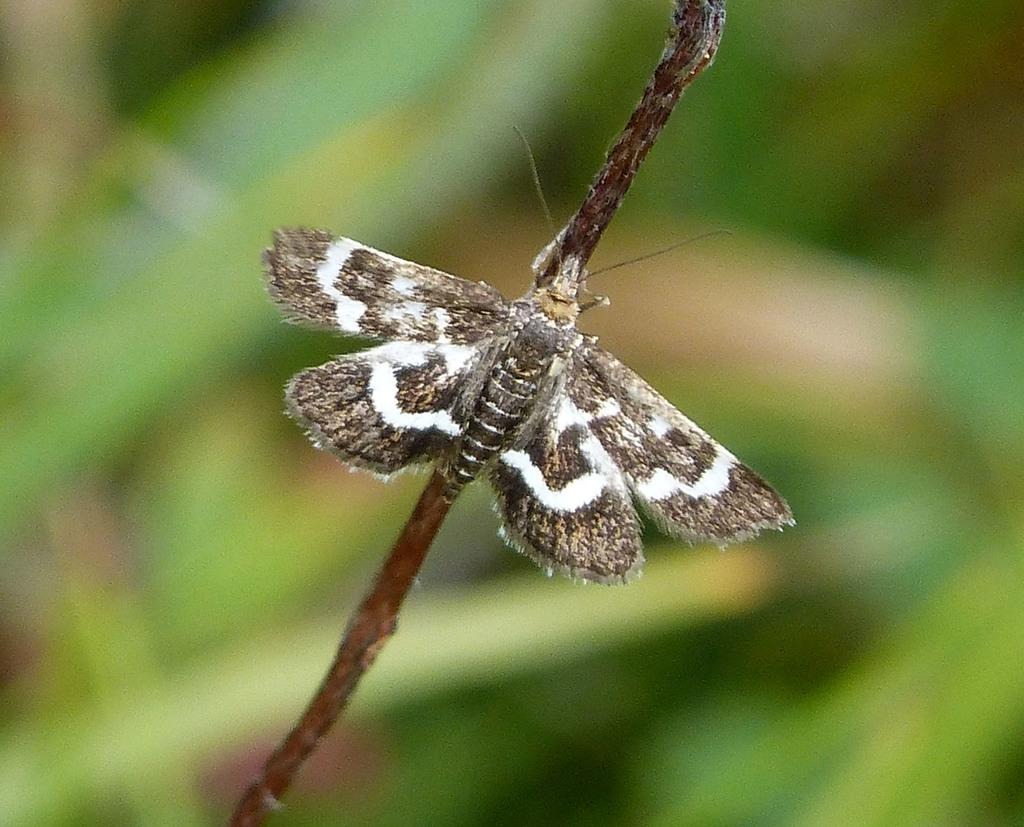What is the main subject of the image? There is a butterfly in the image. Where is the butterfly located in the image? The butterfly is on a stem. What colors can be seen on the butterfly? The butterfly has white and brown colors. What is the color of the background in the image? The background of the image is green. What type of butter is being selected by the visitor in the image? There is no butter or visitor present in the image; it features a butterfly on a stem with a green background. 